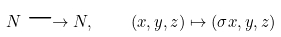Convert formula to latex. <formula><loc_0><loc_0><loc_500><loc_500>N \longrightarrow N , \quad ( x , y , z ) \mapsto ( \sigma x , y , z )</formula> 